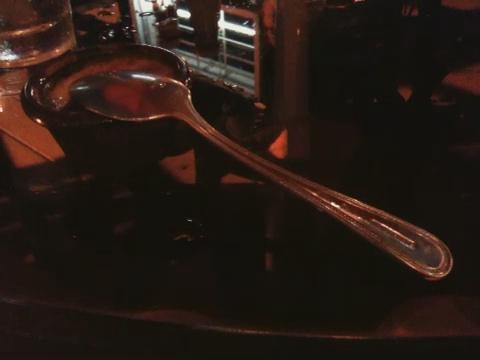How many spoons?
Give a very brief answer. 1. 